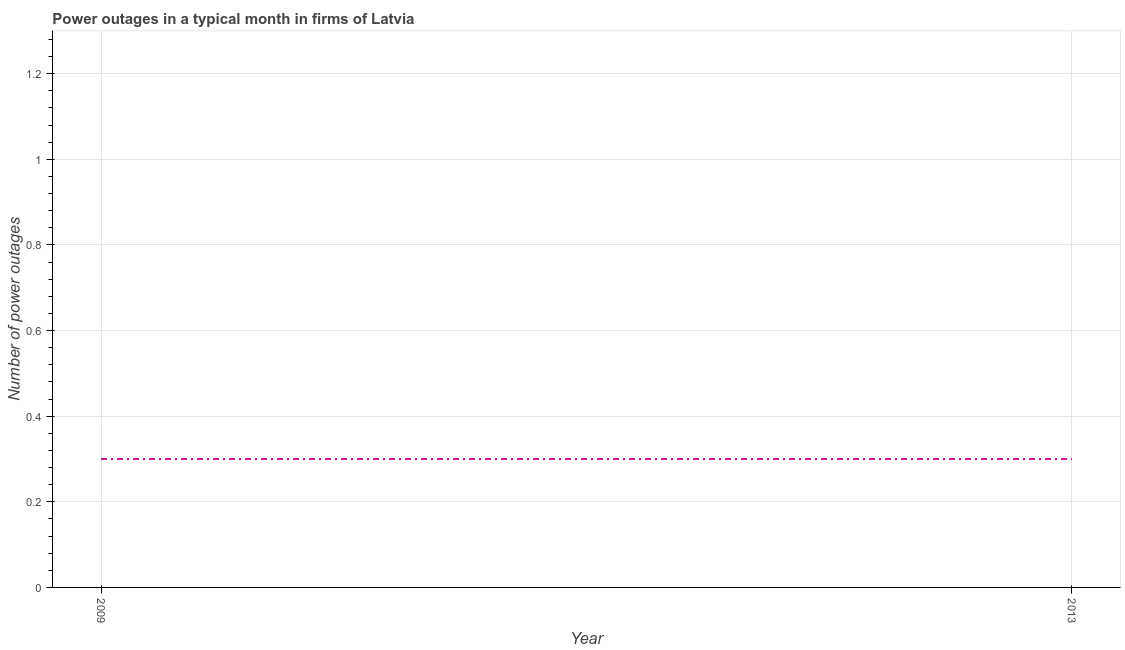What is the number of power outages in 2013?
Provide a succinct answer. 0.3. What is the difference between the number of power outages in 2009 and 2013?
Provide a short and direct response. 0. What is the average number of power outages per year?
Keep it short and to the point. 0.3. What is the median number of power outages?
Offer a terse response. 0.3. What is the ratio of the number of power outages in 2009 to that in 2013?
Provide a short and direct response. 1. Is the number of power outages in 2009 less than that in 2013?
Offer a terse response. No. How many lines are there?
Provide a succinct answer. 1. Are the values on the major ticks of Y-axis written in scientific E-notation?
Offer a terse response. No. Does the graph contain any zero values?
Provide a short and direct response. No. Does the graph contain grids?
Provide a succinct answer. Yes. What is the title of the graph?
Your answer should be compact. Power outages in a typical month in firms of Latvia. What is the label or title of the Y-axis?
Offer a terse response. Number of power outages. What is the Number of power outages of 2009?
Your answer should be compact. 0.3. What is the Number of power outages of 2013?
Your response must be concise. 0.3. What is the difference between the Number of power outages in 2009 and 2013?
Offer a very short reply. 0. What is the ratio of the Number of power outages in 2009 to that in 2013?
Give a very brief answer. 1. 